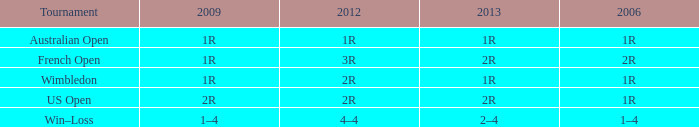What is the Tournament when the 2013 is 2r, and a 2006 is 1r? US Open. 